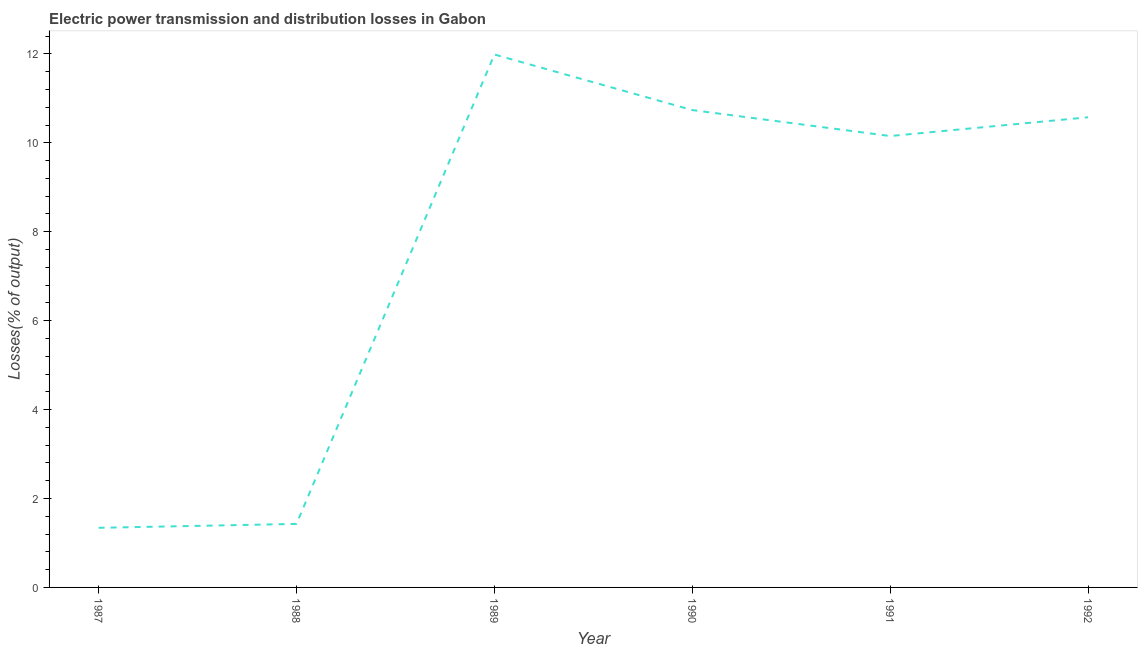What is the electric power transmission and distribution losses in 1991?
Make the answer very short. 10.15. Across all years, what is the maximum electric power transmission and distribution losses?
Keep it short and to the point. 11.99. Across all years, what is the minimum electric power transmission and distribution losses?
Offer a very short reply. 1.34. In which year was the electric power transmission and distribution losses maximum?
Ensure brevity in your answer.  1989. In which year was the electric power transmission and distribution losses minimum?
Make the answer very short. 1987. What is the sum of the electric power transmission and distribution losses?
Keep it short and to the point. 46.22. What is the difference between the electric power transmission and distribution losses in 1987 and 1990?
Ensure brevity in your answer.  -9.4. What is the average electric power transmission and distribution losses per year?
Make the answer very short. 7.7. What is the median electric power transmission and distribution losses?
Your answer should be compact. 10.36. What is the ratio of the electric power transmission and distribution losses in 1989 to that in 1992?
Give a very brief answer. 1.13. Is the electric power transmission and distribution losses in 1988 less than that in 1989?
Ensure brevity in your answer.  Yes. Is the difference between the electric power transmission and distribution losses in 1990 and 1992 greater than the difference between any two years?
Give a very brief answer. No. What is the difference between the highest and the second highest electric power transmission and distribution losses?
Provide a short and direct response. 1.25. Is the sum of the electric power transmission and distribution losses in 1989 and 1992 greater than the maximum electric power transmission and distribution losses across all years?
Provide a short and direct response. Yes. What is the difference between the highest and the lowest electric power transmission and distribution losses?
Provide a succinct answer. 10.65. How many years are there in the graph?
Provide a succinct answer. 6. Are the values on the major ticks of Y-axis written in scientific E-notation?
Give a very brief answer. No. Does the graph contain any zero values?
Provide a short and direct response. No. What is the title of the graph?
Give a very brief answer. Electric power transmission and distribution losses in Gabon. What is the label or title of the Y-axis?
Your answer should be very brief. Losses(% of output). What is the Losses(% of output) in 1987?
Ensure brevity in your answer.  1.34. What is the Losses(% of output) in 1988?
Keep it short and to the point. 1.43. What is the Losses(% of output) in 1989?
Your response must be concise. 11.99. What is the Losses(% of output) of 1990?
Make the answer very short. 10.74. What is the Losses(% of output) of 1991?
Ensure brevity in your answer.  10.15. What is the Losses(% of output) of 1992?
Offer a very short reply. 10.57. What is the difference between the Losses(% of output) in 1987 and 1988?
Your answer should be compact. -0.09. What is the difference between the Losses(% of output) in 1987 and 1989?
Offer a terse response. -10.65. What is the difference between the Losses(% of output) in 1987 and 1990?
Ensure brevity in your answer.  -9.4. What is the difference between the Losses(% of output) in 1987 and 1991?
Your answer should be very brief. -8.81. What is the difference between the Losses(% of output) in 1987 and 1992?
Your response must be concise. -9.23. What is the difference between the Losses(% of output) in 1988 and 1989?
Keep it short and to the point. -10.56. What is the difference between the Losses(% of output) in 1988 and 1990?
Keep it short and to the point. -9.31. What is the difference between the Losses(% of output) in 1988 and 1991?
Give a very brief answer. -8.72. What is the difference between the Losses(% of output) in 1988 and 1992?
Keep it short and to the point. -9.15. What is the difference between the Losses(% of output) in 1989 and 1990?
Provide a succinct answer. 1.25. What is the difference between the Losses(% of output) in 1989 and 1991?
Your answer should be compact. 1.83. What is the difference between the Losses(% of output) in 1989 and 1992?
Your answer should be very brief. 1.41. What is the difference between the Losses(% of output) in 1990 and 1991?
Keep it short and to the point. 0.58. What is the difference between the Losses(% of output) in 1990 and 1992?
Provide a short and direct response. 0.16. What is the difference between the Losses(% of output) in 1991 and 1992?
Give a very brief answer. -0.42. What is the ratio of the Losses(% of output) in 1987 to that in 1988?
Provide a succinct answer. 0.94. What is the ratio of the Losses(% of output) in 1987 to that in 1989?
Ensure brevity in your answer.  0.11. What is the ratio of the Losses(% of output) in 1987 to that in 1991?
Offer a terse response. 0.13. What is the ratio of the Losses(% of output) in 1987 to that in 1992?
Provide a short and direct response. 0.13. What is the ratio of the Losses(% of output) in 1988 to that in 1989?
Give a very brief answer. 0.12. What is the ratio of the Losses(% of output) in 1988 to that in 1990?
Keep it short and to the point. 0.13. What is the ratio of the Losses(% of output) in 1988 to that in 1991?
Your answer should be very brief. 0.14. What is the ratio of the Losses(% of output) in 1988 to that in 1992?
Make the answer very short. 0.14. What is the ratio of the Losses(% of output) in 1989 to that in 1990?
Your answer should be very brief. 1.12. What is the ratio of the Losses(% of output) in 1989 to that in 1991?
Offer a very short reply. 1.18. What is the ratio of the Losses(% of output) in 1989 to that in 1992?
Keep it short and to the point. 1.13. What is the ratio of the Losses(% of output) in 1990 to that in 1991?
Keep it short and to the point. 1.06. What is the ratio of the Losses(% of output) in 1990 to that in 1992?
Make the answer very short. 1.01. 